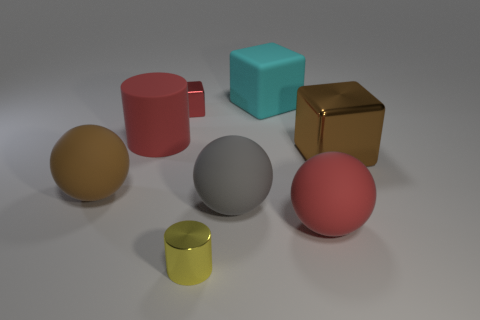What is the material of the large red cylinder?
Make the answer very short. Rubber. The red object behind the red matte object on the left side of the gray rubber thing is what shape?
Provide a short and direct response. Cube. There is a red object that is on the right side of the tiny yellow cylinder; what is its shape?
Provide a short and direct response. Sphere. How many other small shiny cylinders are the same color as the small cylinder?
Your answer should be compact. 0. What color is the big metallic object?
Offer a terse response. Brown. What number of small metal objects are behind the large sphere that is to the left of the gray sphere?
Provide a succinct answer. 1. There is a red cube; is it the same size as the red rubber thing that is in front of the big gray matte thing?
Offer a terse response. No. Do the brown ball and the red cube have the same size?
Make the answer very short. No. Are there any yellow cylinders that have the same size as the cyan object?
Offer a terse response. No. What material is the big red object on the left side of the tiny red cube?
Provide a short and direct response. Rubber. 